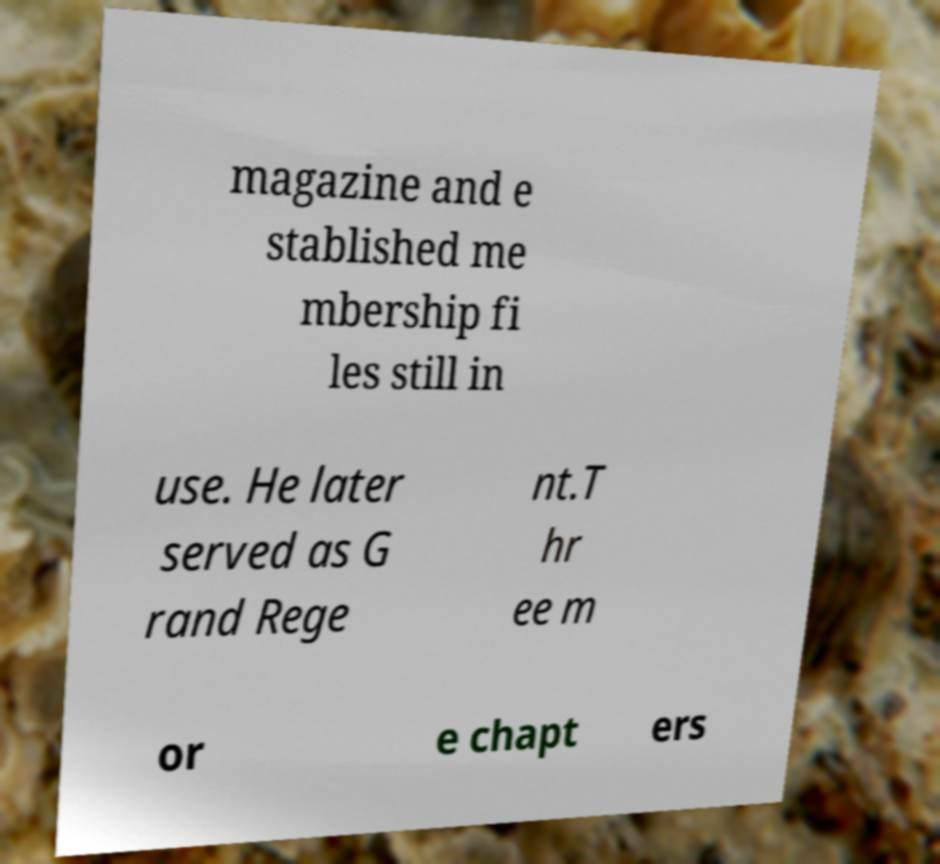Can you read and provide the text displayed in the image?This photo seems to have some interesting text. Can you extract and type it out for me? magazine and e stablished me mbership fi les still in use. He later served as G rand Rege nt.T hr ee m or e chapt ers 